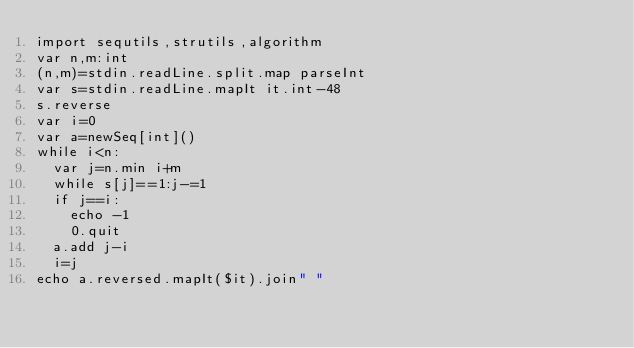<code> <loc_0><loc_0><loc_500><loc_500><_Nim_>import sequtils,strutils,algorithm
var n,m:int
(n,m)=stdin.readLine.split.map parseInt
var s=stdin.readLine.mapIt it.int-48
s.reverse
var i=0
var a=newSeq[int]()
while i<n:
  var j=n.min i+m
  while s[j]==1:j-=1
  if j==i:
    echo -1
    0.quit
  a.add j-i
  i=j
echo a.reversed.mapIt($it).join" "</code> 